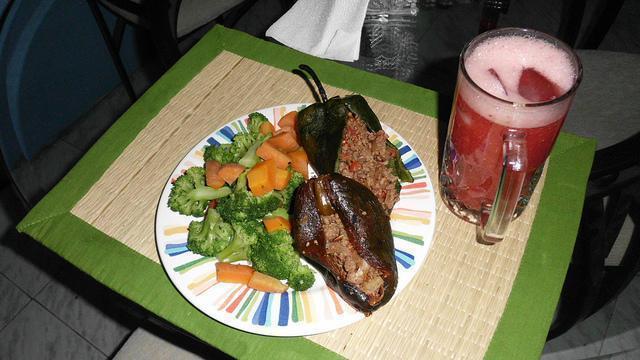What type of drink is in the cup?
Choose the right answer from the provided options to respond to the question.
Options: Water, none, blended juice, beer. Blended juice. 